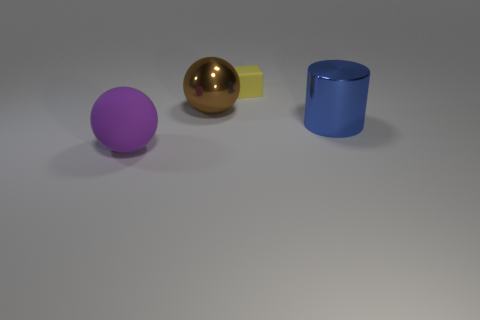How big is the brown thing?
Ensure brevity in your answer.  Large. What color is the large thing that is made of the same material as the block?
Offer a terse response. Purple. What number of big red balls are the same material as the yellow thing?
Keep it short and to the point. 0. There is a rubber object in front of the large brown metallic ball that is on the left side of the blue metal cylinder; what is its color?
Give a very brief answer. Purple. What color is the matte object that is the same size as the cylinder?
Your answer should be compact. Purple. Are there any large blue things that have the same shape as the yellow object?
Make the answer very short. No. The blue shiny thing is what shape?
Make the answer very short. Cylinder. Are there more small yellow rubber objects in front of the brown object than big brown metallic objects in front of the big purple matte thing?
Your response must be concise. No. What number of other things are the same size as the purple rubber ball?
Your response must be concise. 2. There is a object that is behind the rubber sphere and in front of the big metal sphere; what is it made of?
Your answer should be very brief. Metal. 